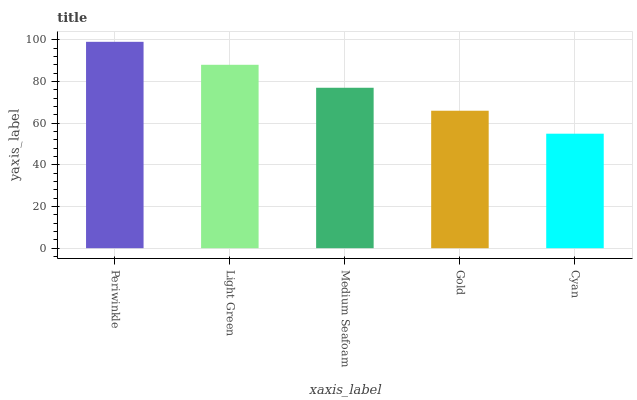Is Cyan the minimum?
Answer yes or no. Yes. Is Periwinkle the maximum?
Answer yes or no. Yes. Is Light Green the minimum?
Answer yes or no. No. Is Light Green the maximum?
Answer yes or no. No. Is Periwinkle greater than Light Green?
Answer yes or no. Yes. Is Light Green less than Periwinkle?
Answer yes or no. Yes. Is Light Green greater than Periwinkle?
Answer yes or no. No. Is Periwinkle less than Light Green?
Answer yes or no. No. Is Medium Seafoam the high median?
Answer yes or no. Yes. Is Medium Seafoam the low median?
Answer yes or no. Yes. Is Cyan the high median?
Answer yes or no. No. Is Periwinkle the low median?
Answer yes or no. No. 